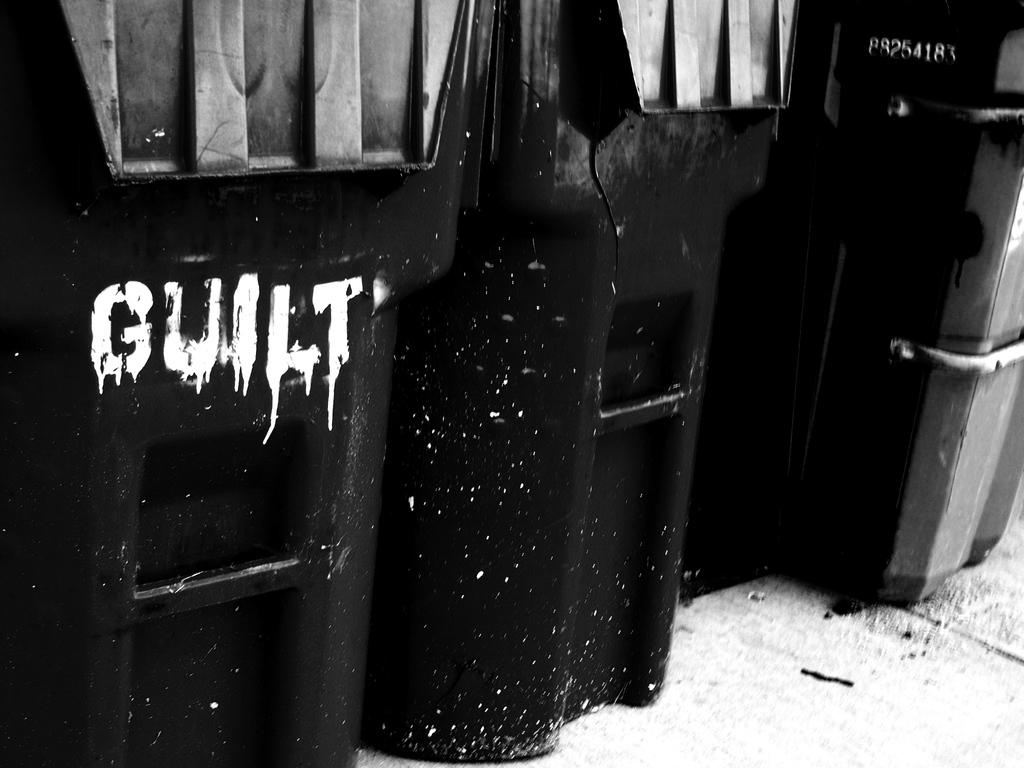<image>
Relay a brief, clear account of the picture shown. A trashcan with the word Guilt spray painted on it. 